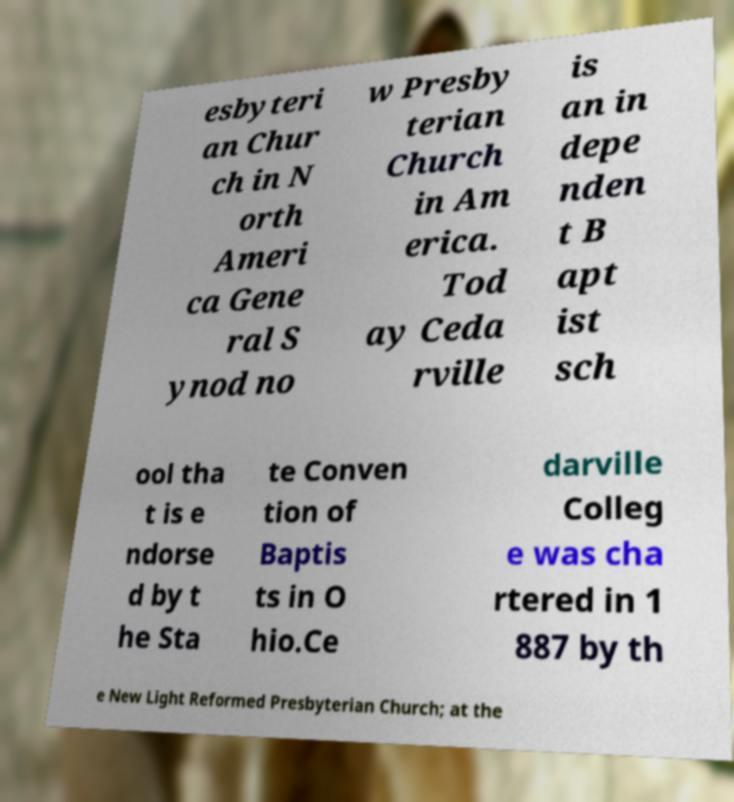Please read and relay the text visible in this image. What does it say? esbyteri an Chur ch in N orth Ameri ca Gene ral S ynod no w Presby terian Church in Am erica. Tod ay Ceda rville is an in depe nden t B apt ist sch ool tha t is e ndorse d by t he Sta te Conven tion of Baptis ts in O hio.Ce darville Colleg e was cha rtered in 1 887 by th e New Light Reformed Presbyterian Church; at the 